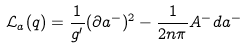<formula> <loc_0><loc_0><loc_500><loc_500>& \mathcal { L } _ { a } ( q ) = \frac { 1 } { g ^ { \prime } } ( \partial a ^ { - } ) ^ { 2 } - \frac { 1 } { 2 n \pi } A ^ { - } d a ^ { - }</formula> 